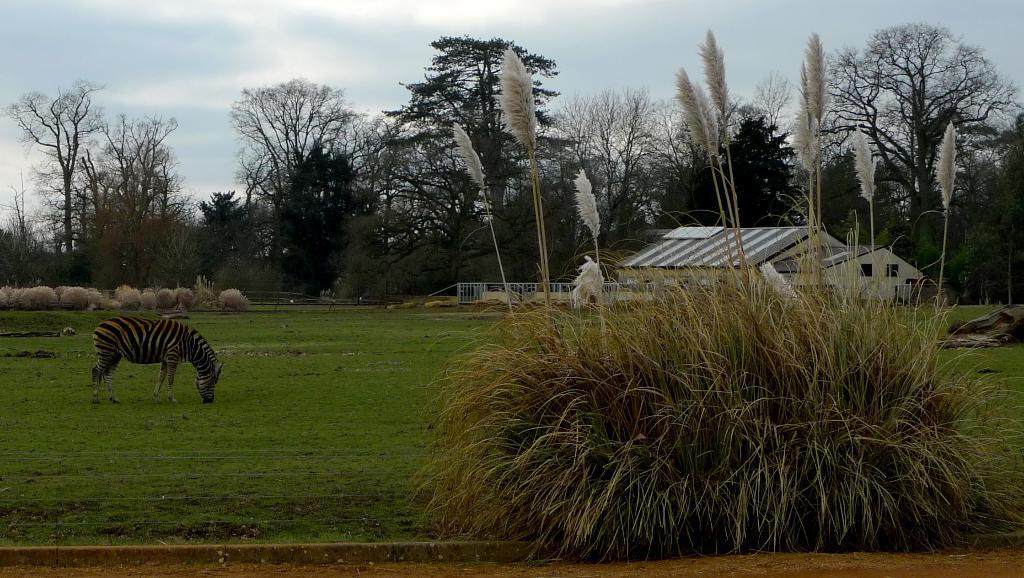What animal is standing in the image? There is a zebra standing in the image. What type of vegetation can be seen in the image? There are plants and trees in the image. What type of structure is present in the image? There is a house in the image. What architectural feature is visible in the image? Iron grills are present in the image. What is visible in the background of the image? The sky is visible in the background of the image. What type of juice is being served in the image? There is no juice present in the image; it features a zebra, plants, a house, iron grills, trees, and the sky. What memory is being triggered by the image? The image does not depict a memory or any personal associations; it is a static representation of the mentioned elements. 